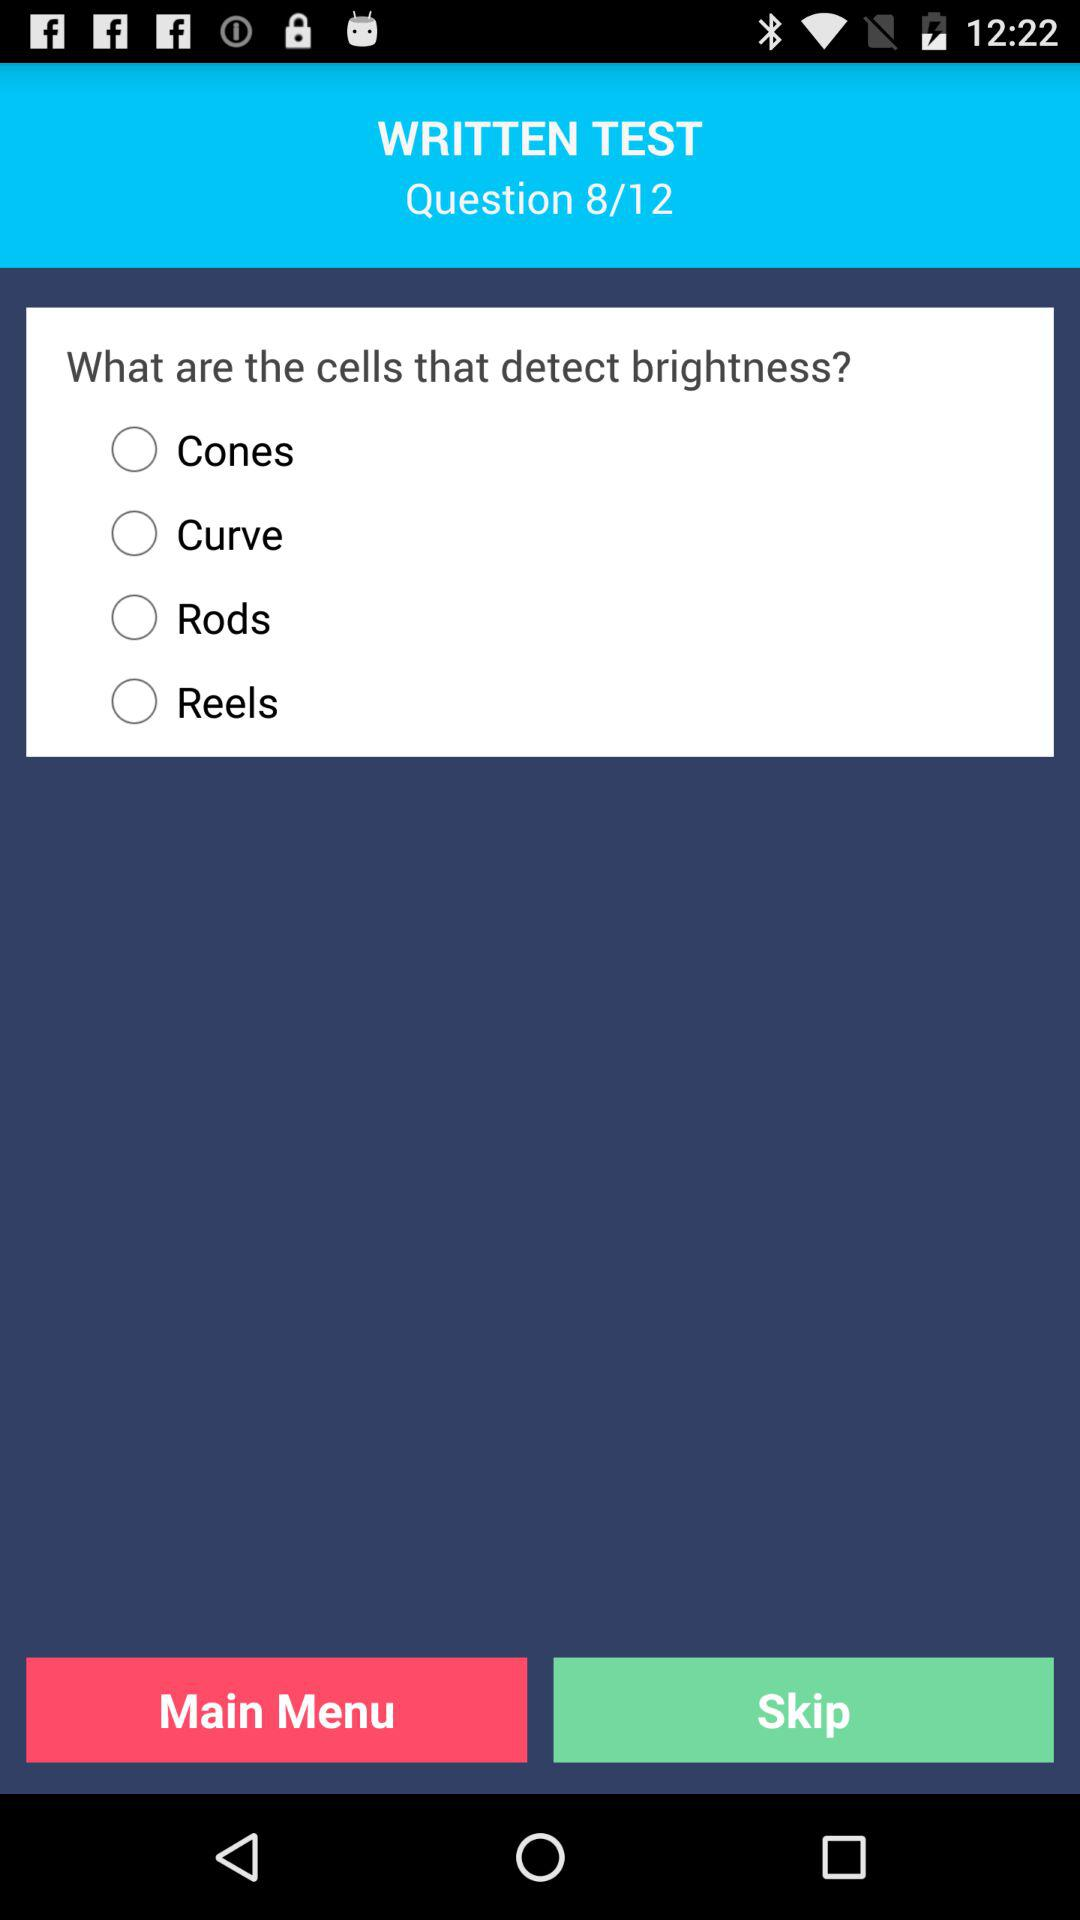What is the number of the current question? The number of the current question is 8. 